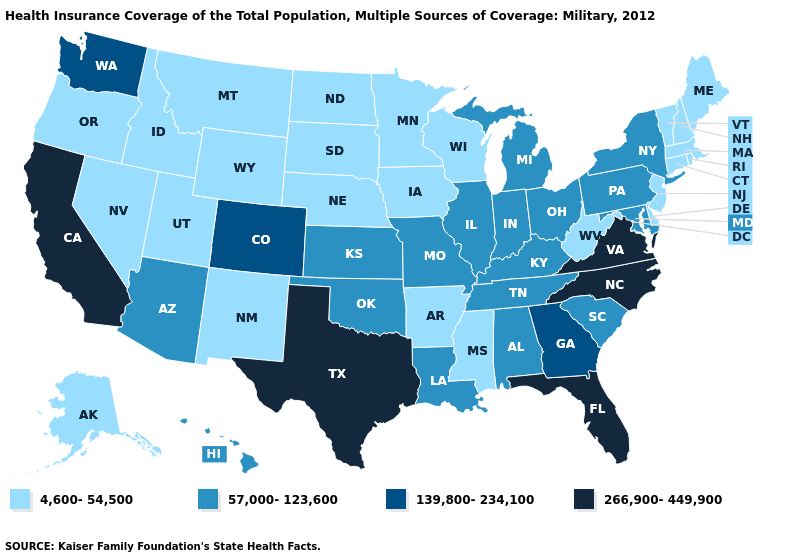Does New York have the highest value in the USA?
Write a very short answer. No. Which states have the highest value in the USA?
Concise answer only. California, Florida, North Carolina, Texas, Virginia. Name the states that have a value in the range 57,000-123,600?
Answer briefly. Alabama, Arizona, Hawaii, Illinois, Indiana, Kansas, Kentucky, Louisiana, Maryland, Michigan, Missouri, New York, Ohio, Oklahoma, Pennsylvania, South Carolina, Tennessee. What is the highest value in states that border Ohio?
Quick response, please. 57,000-123,600. Which states have the lowest value in the USA?
Write a very short answer. Alaska, Arkansas, Connecticut, Delaware, Idaho, Iowa, Maine, Massachusetts, Minnesota, Mississippi, Montana, Nebraska, Nevada, New Hampshire, New Jersey, New Mexico, North Dakota, Oregon, Rhode Island, South Dakota, Utah, Vermont, West Virginia, Wisconsin, Wyoming. Which states hav the highest value in the South?
Be succinct. Florida, North Carolina, Texas, Virginia. What is the value of Mississippi?
Write a very short answer. 4,600-54,500. Name the states that have a value in the range 139,800-234,100?
Answer briefly. Colorado, Georgia, Washington. What is the value of Utah?
Concise answer only. 4,600-54,500. What is the lowest value in the USA?
Keep it brief. 4,600-54,500. Name the states that have a value in the range 4,600-54,500?
Keep it brief. Alaska, Arkansas, Connecticut, Delaware, Idaho, Iowa, Maine, Massachusetts, Minnesota, Mississippi, Montana, Nebraska, Nevada, New Hampshire, New Jersey, New Mexico, North Dakota, Oregon, Rhode Island, South Dakota, Utah, Vermont, West Virginia, Wisconsin, Wyoming. Name the states that have a value in the range 266,900-449,900?
Keep it brief. California, Florida, North Carolina, Texas, Virginia. Among the states that border New York , does New Jersey have the lowest value?
Short answer required. Yes. What is the value of Alaska?
Give a very brief answer. 4,600-54,500. Name the states that have a value in the range 57,000-123,600?
Give a very brief answer. Alabama, Arizona, Hawaii, Illinois, Indiana, Kansas, Kentucky, Louisiana, Maryland, Michigan, Missouri, New York, Ohio, Oklahoma, Pennsylvania, South Carolina, Tennessee. 